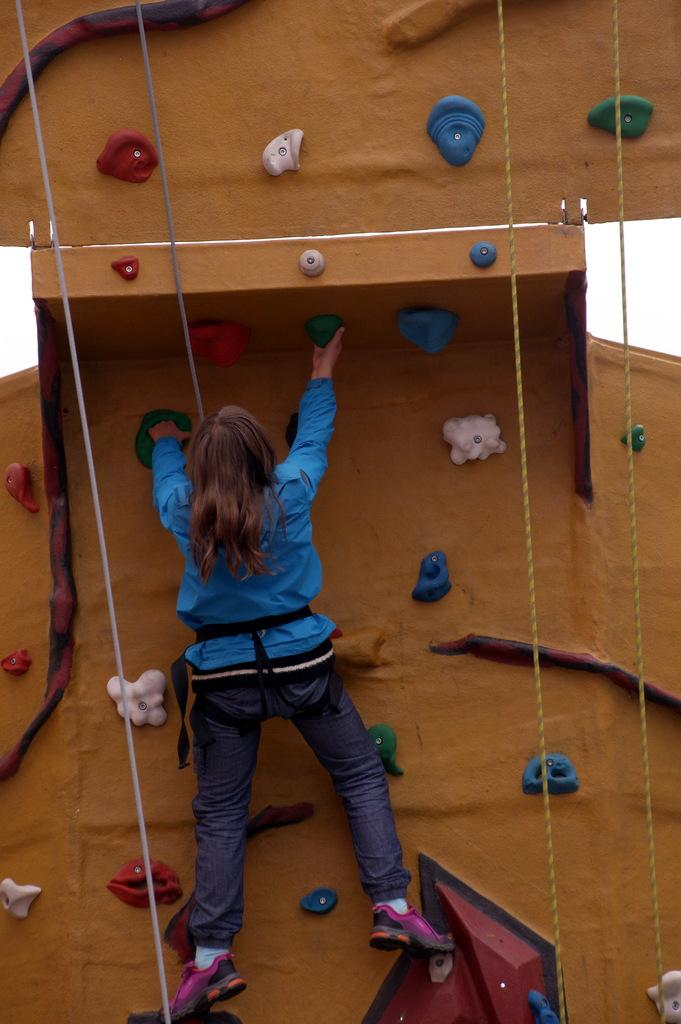Who is the main subject in the image? There is a woman in the image. What is the woman wearing? The woman is wearing a blue t-shirt. What is the woman doing in the image? The woman is climbing on a wall. Can you describe the wall in the image? The wall has ropes on it and is brown in color. How many centimeters long is the shelf in the image? There is no shelf present in the image. What type of flag is visible on the wall in the image? There is no flag visible on the wall in the image. 